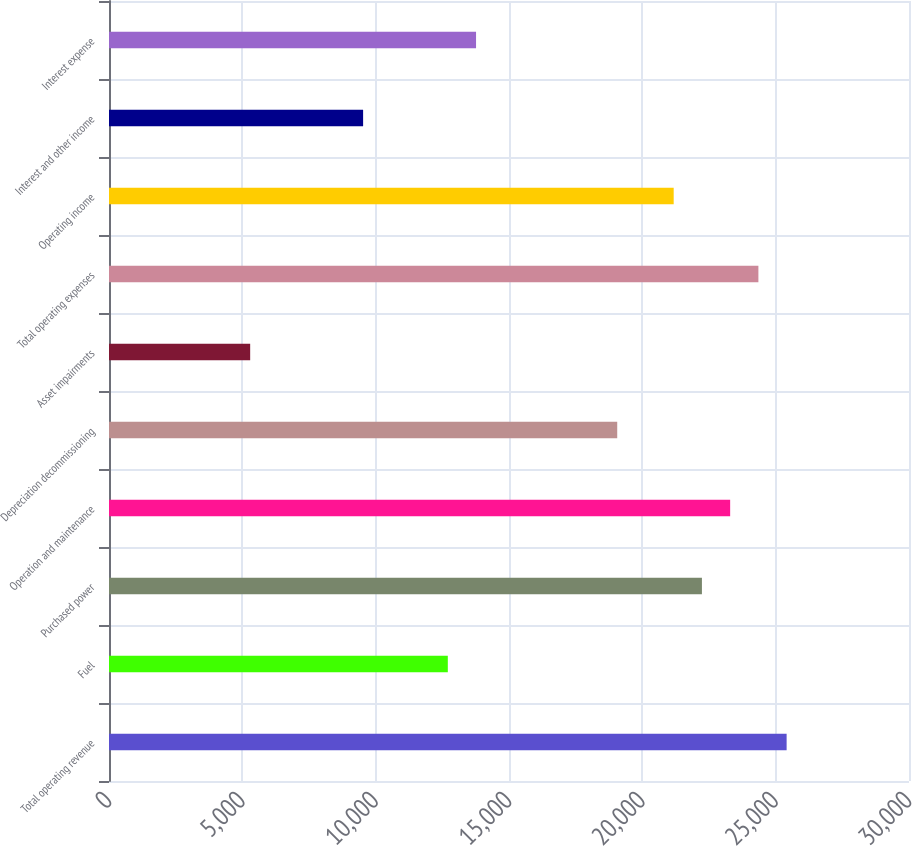Convert chart. <chart><loc_0><loc_0><loc_500><loc_500><bar_chart><fcel>Total operating revenue<fcel>Fuel<fcel>Purchased power<fcel>Operation and maintenance<fcel>Depreciation decommissioning<fcel>Asset impairments<fcel>Total operating expenses<fcel>Operating income<fcel>Interest and other income<fcel>Interest expense<nl><fcel>25411.1<fcel>12705.6<fcel>22234.7<fcel>23293.5<fcel>19058.3<fcel>5294.06<fcel>24352.3<fcel>21175.9<fcel>9529.22<fcel>13764.4<nl></chart> 